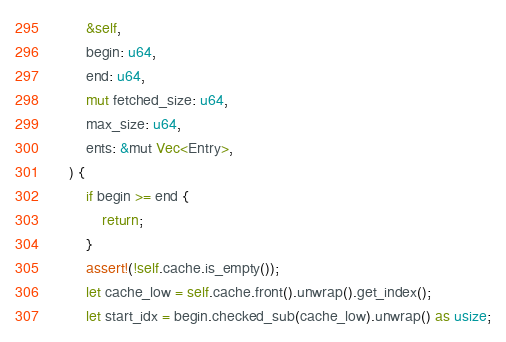<code> <loc_0><loc_0><loc_500><loc_500><_Rust_>        &self,
        begin: u64,
        end: u64,
        mut fetched_size: u64,
        max_size: u64,
        ents: &mut Vec<Entry>,
    ) {
        if begin >= end {
            return;
        }
        assert!(!self.cache.is_empty());
        let cache_low = self.cache.front().unwrap().get_index();
        let start_idx = begin.checked_sub(cache_low).unwrap() as usize;</code> 